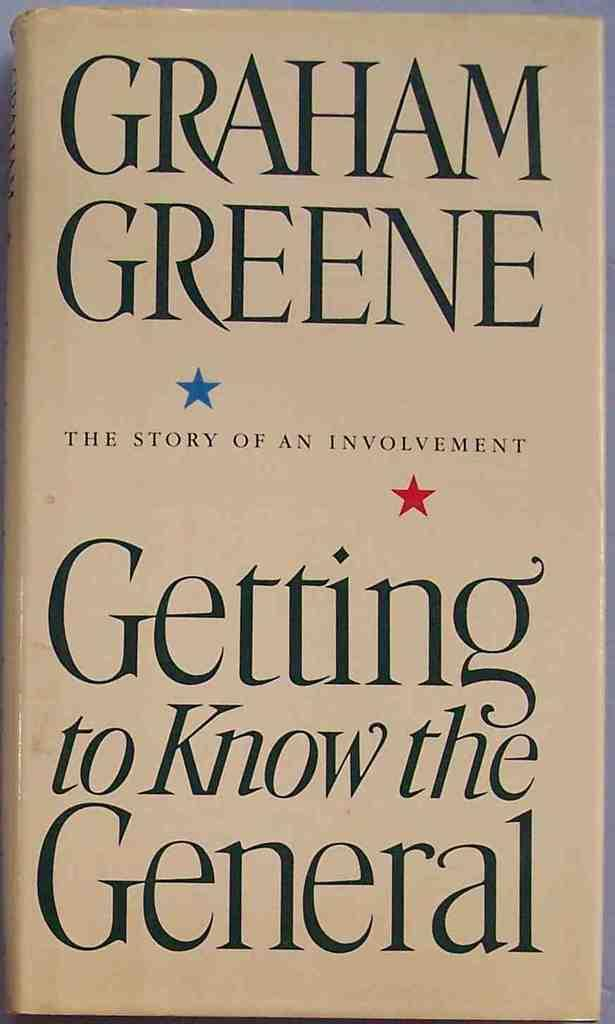<image>
Relay a brief, clear account of the picture shown. The book cover of Getting to Know the General includes two small stars. 